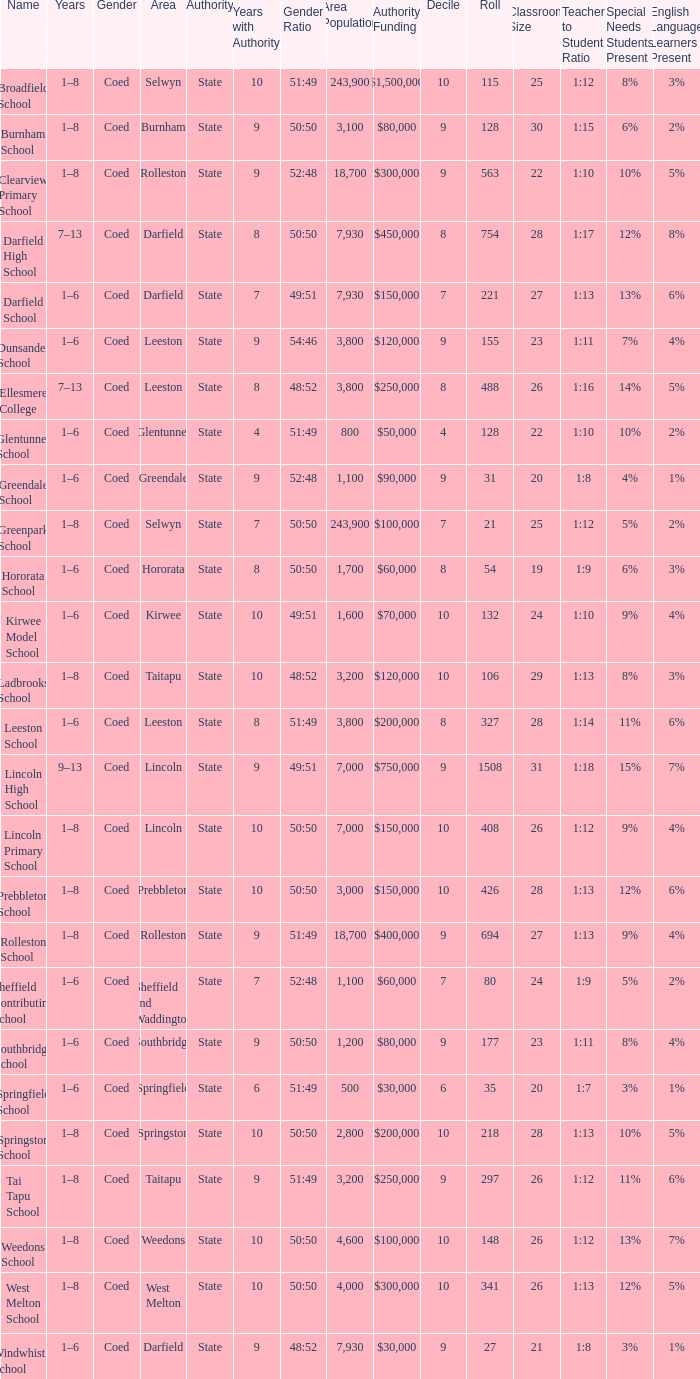Which area has a Decile of 9, and a Roll of 31? Greendale. Parse the table in full. {'header': ['Name', 'Years', 'Gender', 'Area', 'Authority', 'Years with Authority', 'Gender Ratio', 'Area Population', 'Authority Funding', 'Decile', 'Roll', 'Classroom Size', 'Teacher to Student Ratio', 'Special Needs Students Present', 'English Language Learners Present '], 'rows': [['Broadfield School', '1–8', 'Coed', 'Selwyn', 'State', '10', '51:49', '243,900', '$1,500,000', '10', '115', '25', '1:12', '8%', '3%'], ['Burnham School', '1–8', 'Coed', 'Burnham', 'State', '9', '50:50', '3,100', '$80,000', '9', '128', '30', '1:15', '6%', '2%'], ['Clearview Primary School', '1–8', 'Coed', 'Rolleston', 'State', '9', '52:48', '18,700', '$300,000', '9', '563', '22', '1:10', '10%', '5%'], ['Darfield High School', '7–13', 'Coed', 'Darfield', 'State', '8', '50:50', '7,930', '$450,000', '8', '754', '28', '1:17', '12%', '8%'], ['Darfield School', '1–6', 'Coed', 'Darfield', 'State', '7', '49:51', '7,930', '$150,000', '7', '221', '27', '1:13', '13%', '6%'], ['Dunsandel School', '1–6', 'Coed', 'Leeston', 'State', '9', '54:46', '3,800', '$120,000', '9', '155', '23', '1:11', '7%', '4%'], ['Ellesmere College', '7–13', 'Coed', 'Leeston', 'State', '8', '48:52', '3,800', '$250,000', '8', '488', '26', '1:16', '14%', '5%'], ['Glentunnel School', '1–6', 'Coed', 'Glentunnel', 'State', '4', '51:49', '800', '$50,000', '4', '128', '22', '1:10', '10%', '2%'], ['Greendale School', '1–6', 'Coed', 'Greendale', 'State', '9', '52:48', '1,100', '$90,000', '9', '31', '20', '1:8', '4%', '1%'], ['Greenpark School', '1–8', 'Coed', 'Selwyn', 'State', '7', '50:50', '243,900', '$100,000', '7', '21', '25', '1:12', '5%', '2%'], ['Hororata School', '1–6', 'Coed', 'Hororata', 'State', '8', '50:50', '1,700', '$60,000', '8', '54', '19', '1:9', '6%', '3%'], ['Kirwee Model School', '1–6', 'Coed', 'Kirwee', 'State', '10', '49:51', '1,600', '$70,000', '10', '132', '24', '1:10', '9%', '4%'], ['Ladbrooks School', '1–8', 'Coed', 'Taitapu', 'State', '10', '48:52', '3,200', '$120,000', '10', '106', '29', '1:13', '8%', '3%'], ['Leeston School', '1–6', 'Coed', 'Leeston', 'State', '8', '51:49', '3,800', '$200,000', '8', '327', '28', '1:14', '11%', '6%'], ['Lincoln High School', '9–13', 'Coed', 'Lincoln', 'State', '9', '49:51', '7,000', '$750,000', '9', '1508', '31', '1:18', '15%', '7%'], ['Lincoln Primary School', '1–8', 'Coed', 'Lincoln', 'State', '10', '50:50', '7,000', '$150,000', '10', '408', '26', '1:12', '9%', '4%'], ['Prebbleton School', '1–8', 'Coed', 'Prebbleton', 'State', '10', '50:50', '3,000', '$150,000', '10', '426', '28', '1:13', '12%', '6%'], ['Rolleston School', '1–8', 'Coed', 'Rolleston', 'State', '9', '51:49', '18,700', '$400,000', '9', '694', '27', '1:13', '9%', '4%'], ['Sheffield Contributing School', '1–6', 'Coed', 'Sheffield and Waddington', 'State', '7', '52:48', '1,100', '$60,000', '7', '80', '24', '1:9', '5%', '2%'], ['Southbridge School', '1–6', 'Coed', 'Southbridge', 'State', '9', '50:50', '1,200', '$80,000', '9', '177', '23', '1:11', '8%', '4%'], ['Springfield School', '1–6', 'Coed', 'Springfield', 'State', '6', '51:49', '500', '$30,000', '6', '35', '20', '1:7', '3%', '1%'], ['Springston School', '1–8', 'Coed', 'Springston', 'State', '10', '50:50', '2,800', '$200,000', '10', '218', '28', '1:13', '10%', '5%'], ['Tai Tapu School', '1–8', 'Coed', 'Taitapu', 'State', '9', '51:49', '3,200', '$250,000', '9', '297', '26', '1:12', '11%', '6%'], ['Weedons School', '1–8', 'Coed', 'Weedons', 'State', '10', '50:50', '4,600', '$100,000', '10', '148', '26', '1:12', '13%', '7%'], ['West Melton School', '1–8', 'Coed', 'West Melton', 'State', '10', '50:50', '4,000', '$300,000', '10', '341', '26', '1:13', '12%', '5%'], ['Windwhistle School', '1–6', 'Coed', 'Darfield', 'State', '9', '48:52', '7,930', '$30,000', '9', '27', '21', '1:8', '3%', '1%']]} 